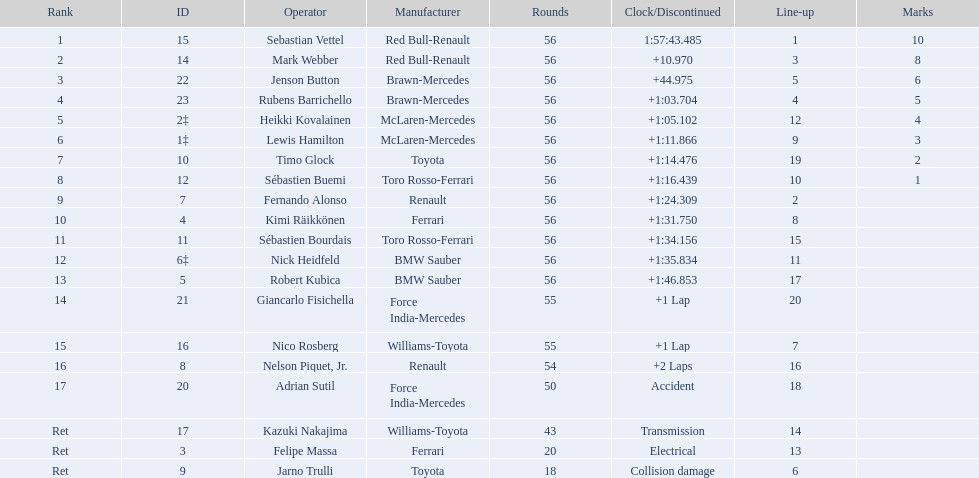What is the total number of laps in the race? 56. 